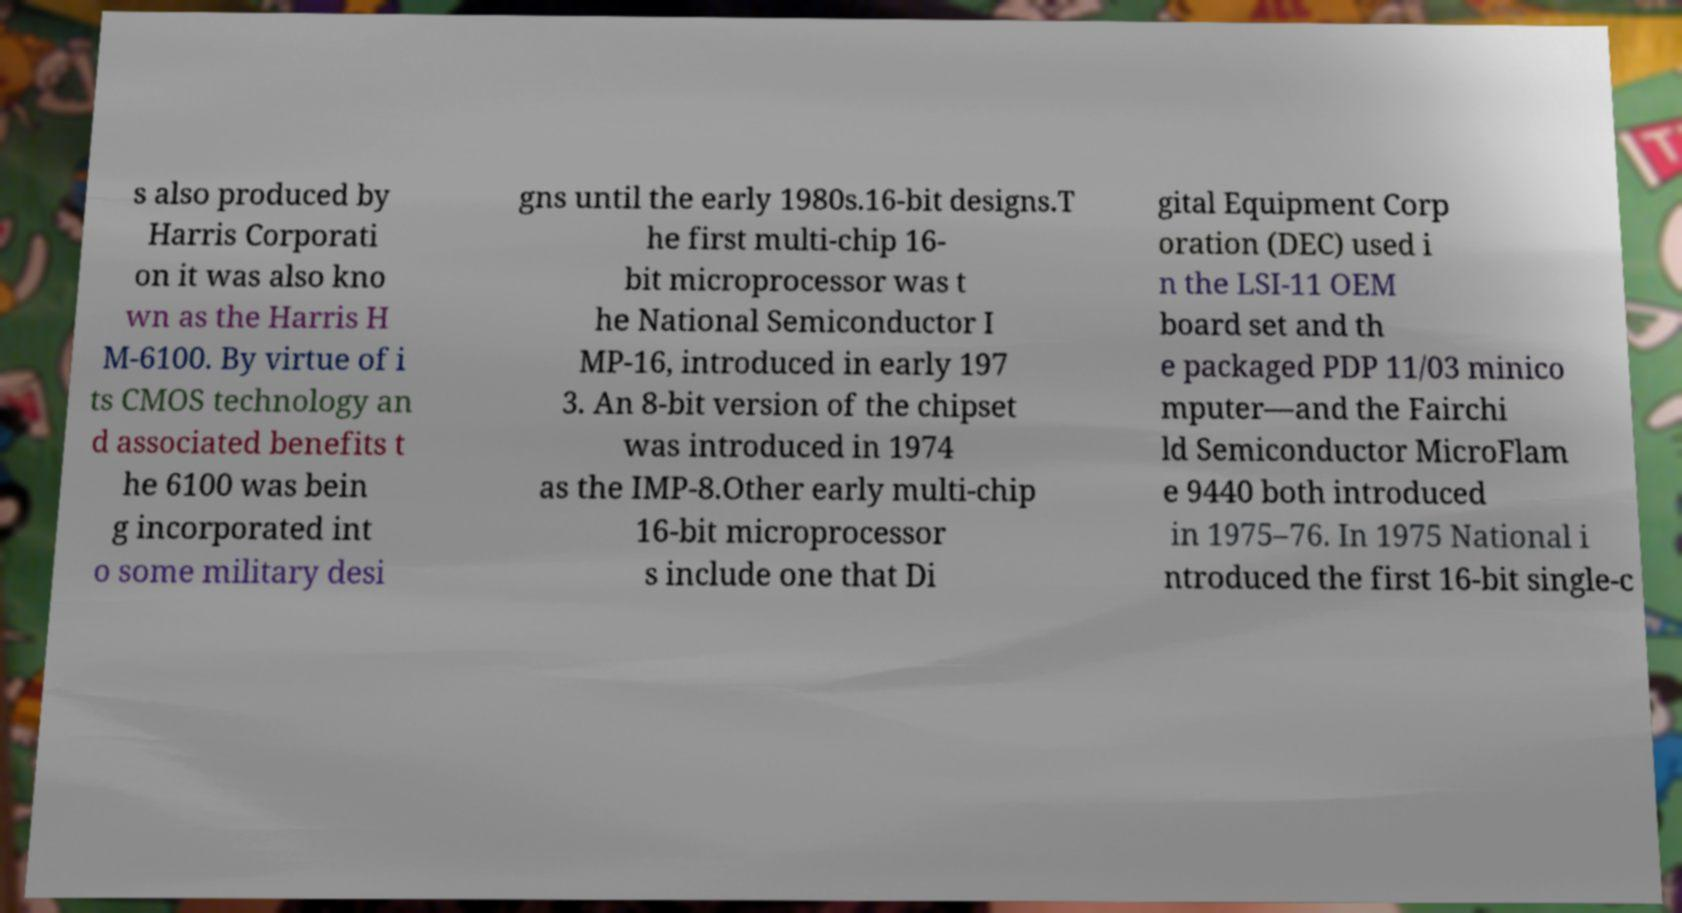Could you extract and type out the text from this image? s also produced by Harris Corporati on it was also kno wn as the Harris H M-6100. By virtue of i ts CMOS technology an d associated benefits t he 6100 was bein g incorporated int o some military desi gns until the early 1980s.16-bit designs.T he first multi-chip 16- bit microprocessor was t he National Semiconductor I MP-16, introduced in early 197 3. An 8-bit version of the chipset was introduced in 1974 as the IMP-8.Other early multi-chip 16-bit microprocessor s include one that Di gital Equipment Corp oration (DEC) used i n the LSI-11 OEM board set and th e packaged PDP 11/03 minico mputer—and the Fairchi ld Semiconductor MicroFlam e 9440 both introduced in 1975–76. In 1975 National i ntroduced the first 16-bit single-c 